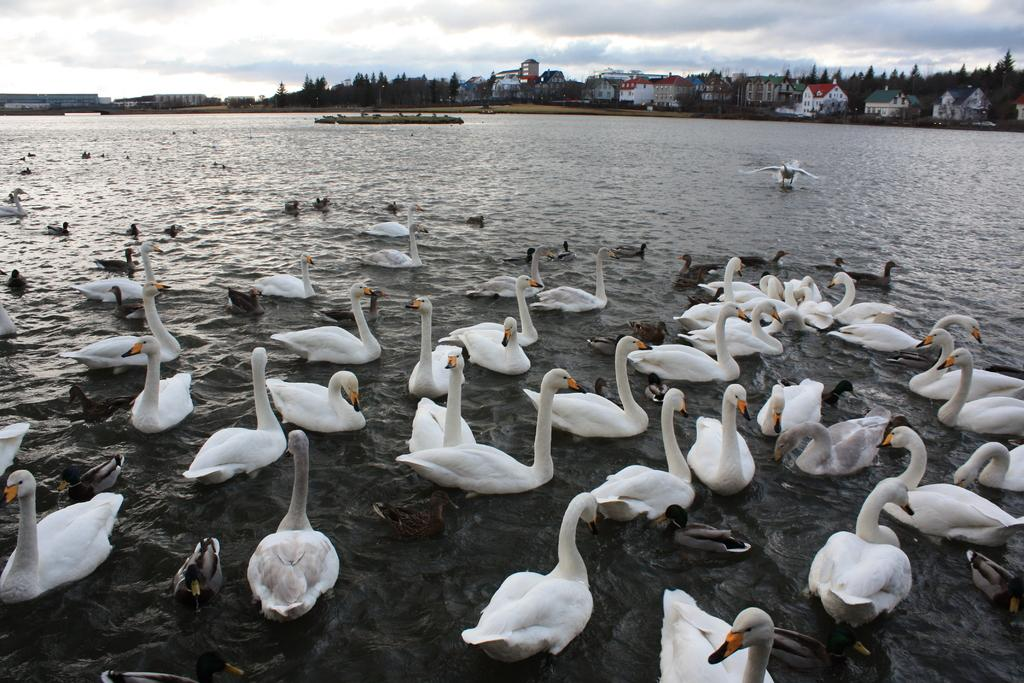What animals can be seen in the image? There are swans in the image. Where are the swans located? The swans are in a river. What can be seen in the background of the image? There are houses, trees, and the sky visible in the background of the image. What type of note is being played by the swans in the image? There is no indication in the image that the swans are playing a note or making any sounds. 